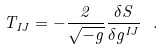Convert formula to latex. <formula><loc_0><loc_0><loc_500><loc_500>T _ { I J } = - \frac { 2 } { \sqrt { - g } } \frac { \delta S } { \delta g ^ { I J } } \ .</formula> 